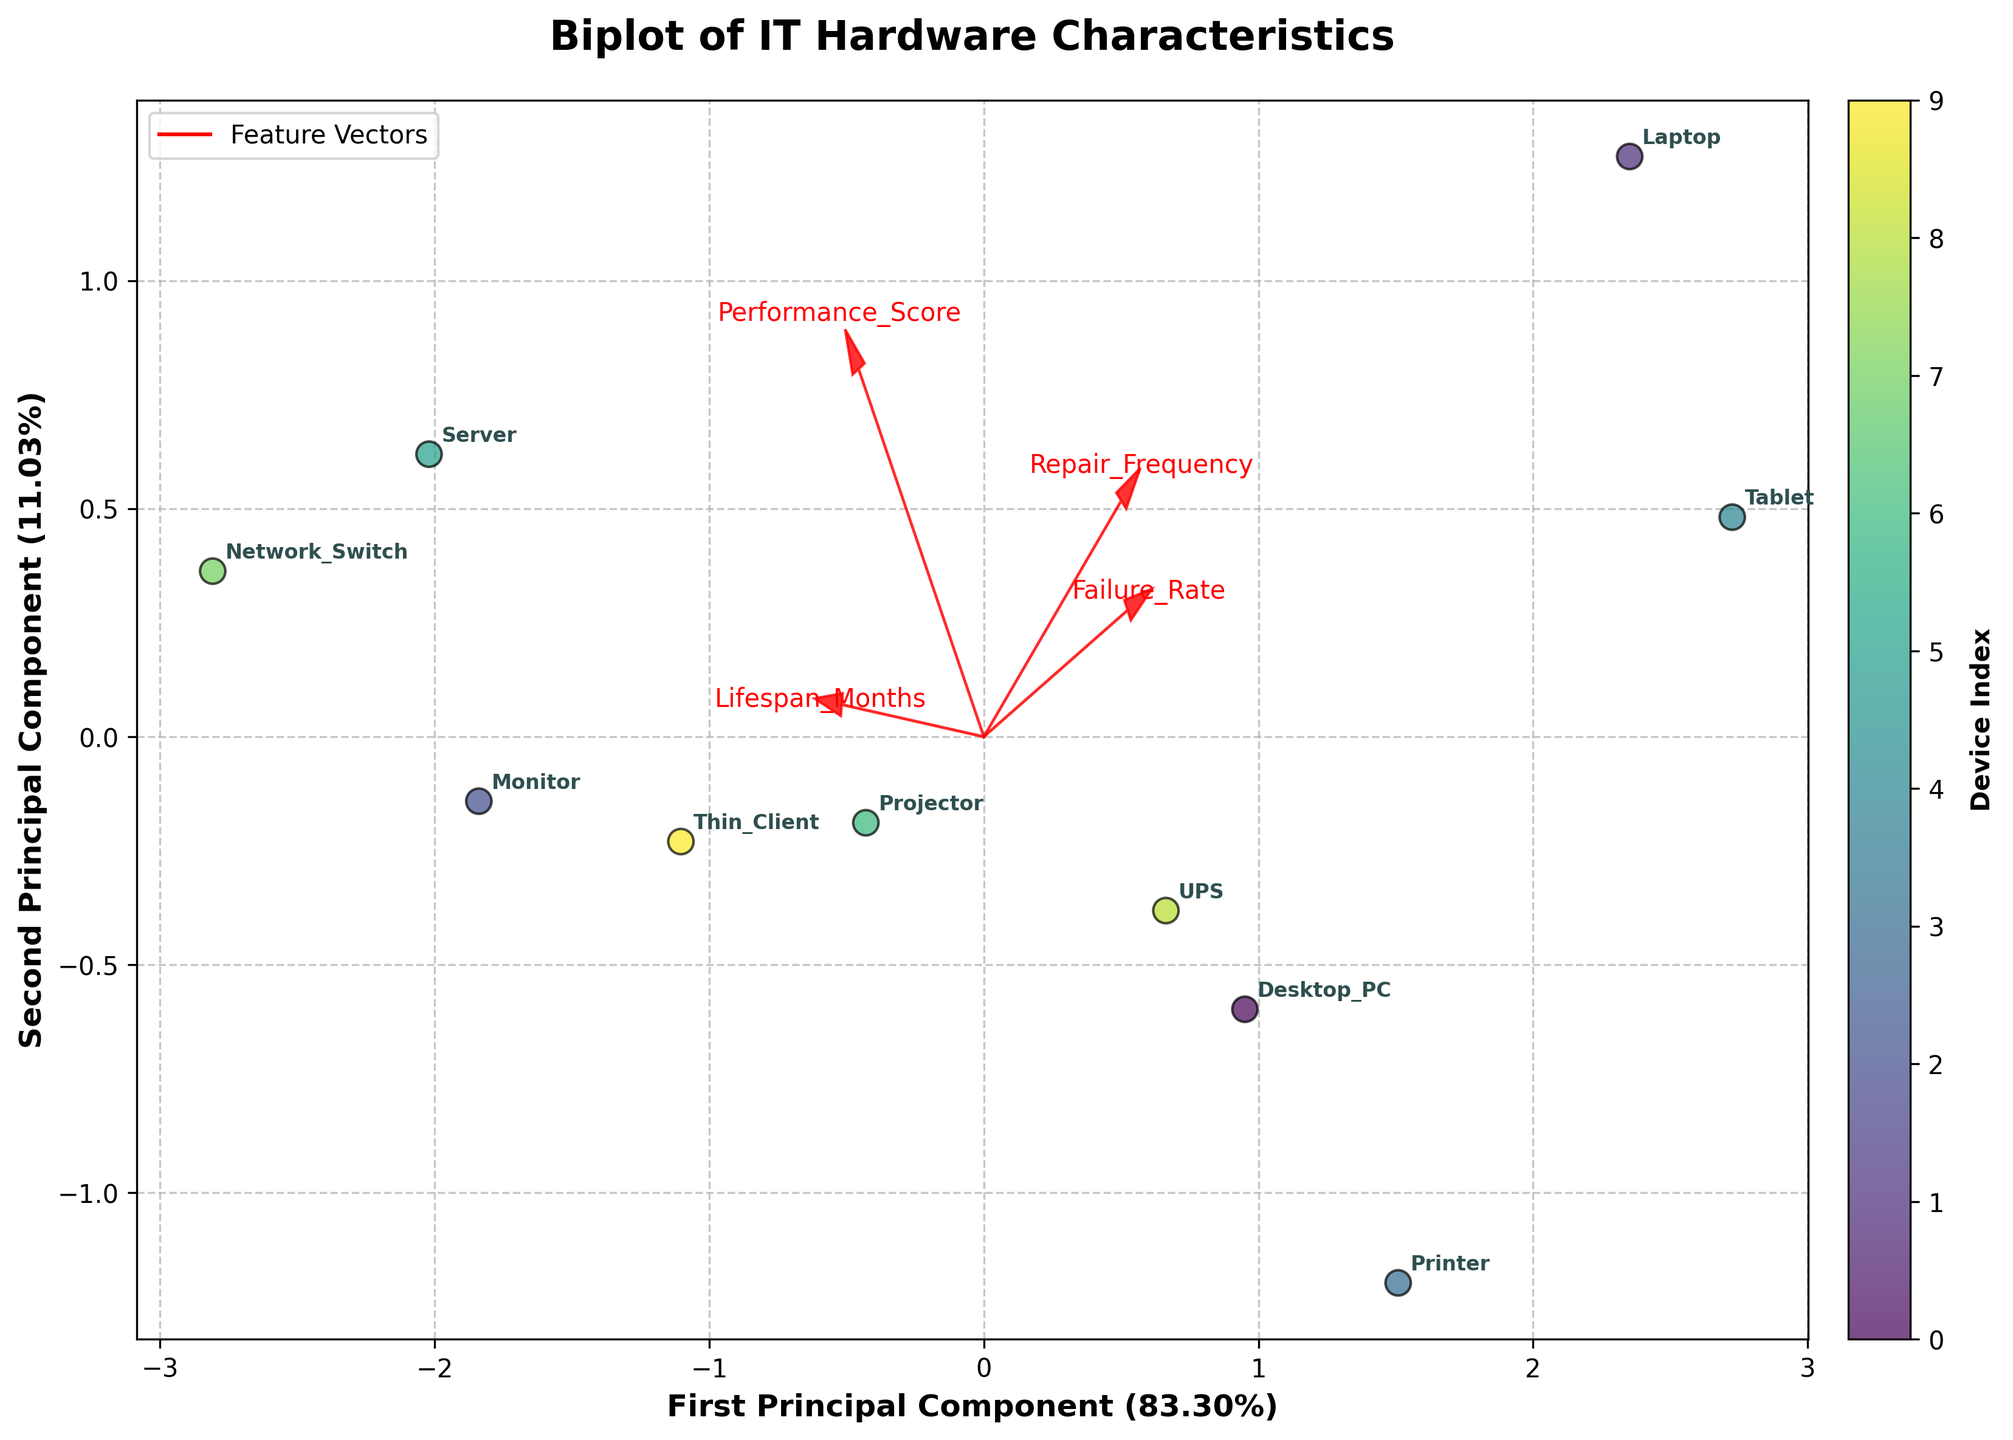What's the title of the plot? The title of the plot is usually displayed at the top of the figure, and it summarizes the main idea of the plot. Here it reads "Biplot of IT Hardware Characteristics."
Answer: Biplot of IT Hardware Characteristics How many different device types are represented in the plot? Each device type is represented by a label on the scatter plot. Count the unique labels to find the number of different device types. Here we have Desktop_PC, Laptop, Monitor, Printer, Tablet, Server, Projector, Network_Switch, UPS, Thin_Client.
Answer: 10 Which device has the highest Repair Frequency? To determine the device with the highest Repair Frequency, look at the position of the data points along the repair frequency axis and find the corresponding label. Higher Repair Frequency corresponds to a more positive direction of the feature vector.
Answer: Laptop What is the significant difference between Desktop_PC and Server in terms of lifespan and repair frequency? From the Biplot, look at the positioning of Desktop_PC and Server in relation to the Lifespan_Months and Repair_Frequency feature vectors. Desktop_PC is closer to a higher Repair_Frequency and lower Lifespan, while Server has a longer lifespan and lower repair frequency.
Answer: Desktop_PC has a shorter lifespan and higher repair frequency compared to Server Which device clusters closest to the Performance_Score vector? Examine the scatter plot and identify which device lies nearest to the direction of the Performance_Score feature vector. The device closest to this vector is most influenced by its high performance score.
Answer: Server How does the UPS compare with the Thin_Client in terms of Failure Rate and Performance Score? Observe the position of UPS and Thin_Client relative to the Failure_Rate and Performance_Score vectors. Thin_Client appears to have a lower Failure Rate and slightly better Performance Score compared to UPS.
Answer: Thin_Client has a lower failure rate and slightly better performance score compared to UPS What percentage of variance is explained by the first principal component? The percentage of variance explained by the first principal component is typically labeled along the x-axis, here it is mentioned.
Answer: around 55% Which two devices are the outliers with the shortest lifespan and highest repair frequency? From the plot, identify the devices that are positioned farthest in the direction associated with short lifespan and high repair frequency.
Answer: Tablet and Laptop How is Network_Switch represented in relation to the Lifespan_Months feature vector? Find the position of Network_Switch on the plot and note its alignment with the Lifespan_Months feature vector. Network_Switch is positioned in the direction indicating a long lifespan.
Answer: Network_Switch has a long lifespan Which feature contributes most to the second principal component? The feature that contributes most to the second principal component is the one whose arrow vector points mostly in the direction of the second principal component (y-axis). Look at the length and direction of the vectors relative to this axis.
Answer: Performance_Score 